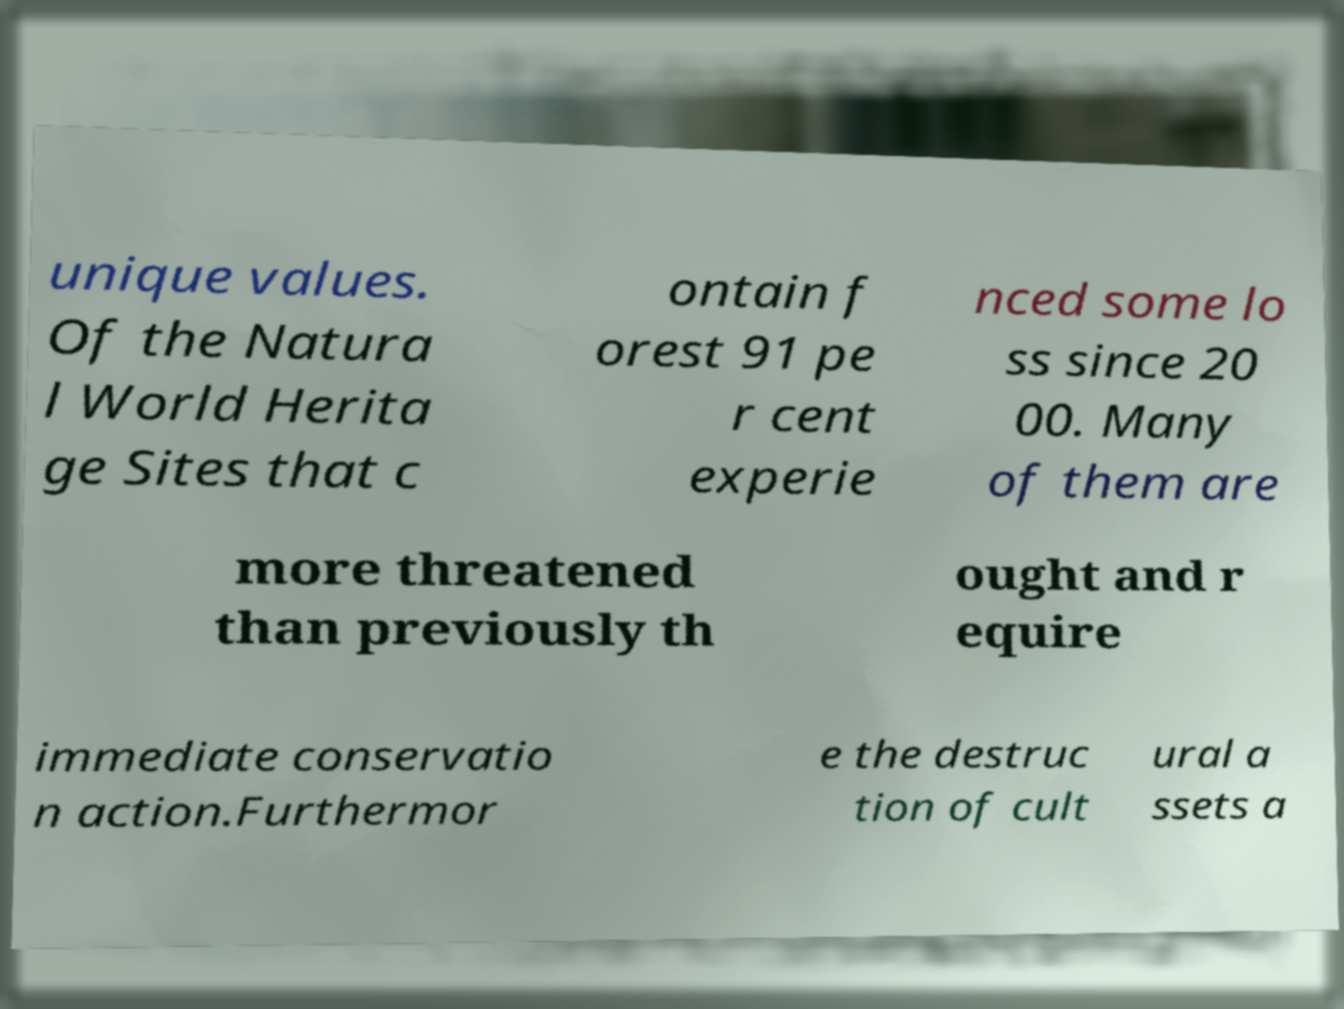Can you accurately transcribe the text from the provided image for me? unique values. Of the Natura l World Herita ge Sites that c ontain f orest 91 pe r cent experie nced some lo ss since 20 00. Many of them are more threatened than previously th ought and r equire immediate conservatio n action.Furthermor e the destruc tion of cult ural a ssets a 